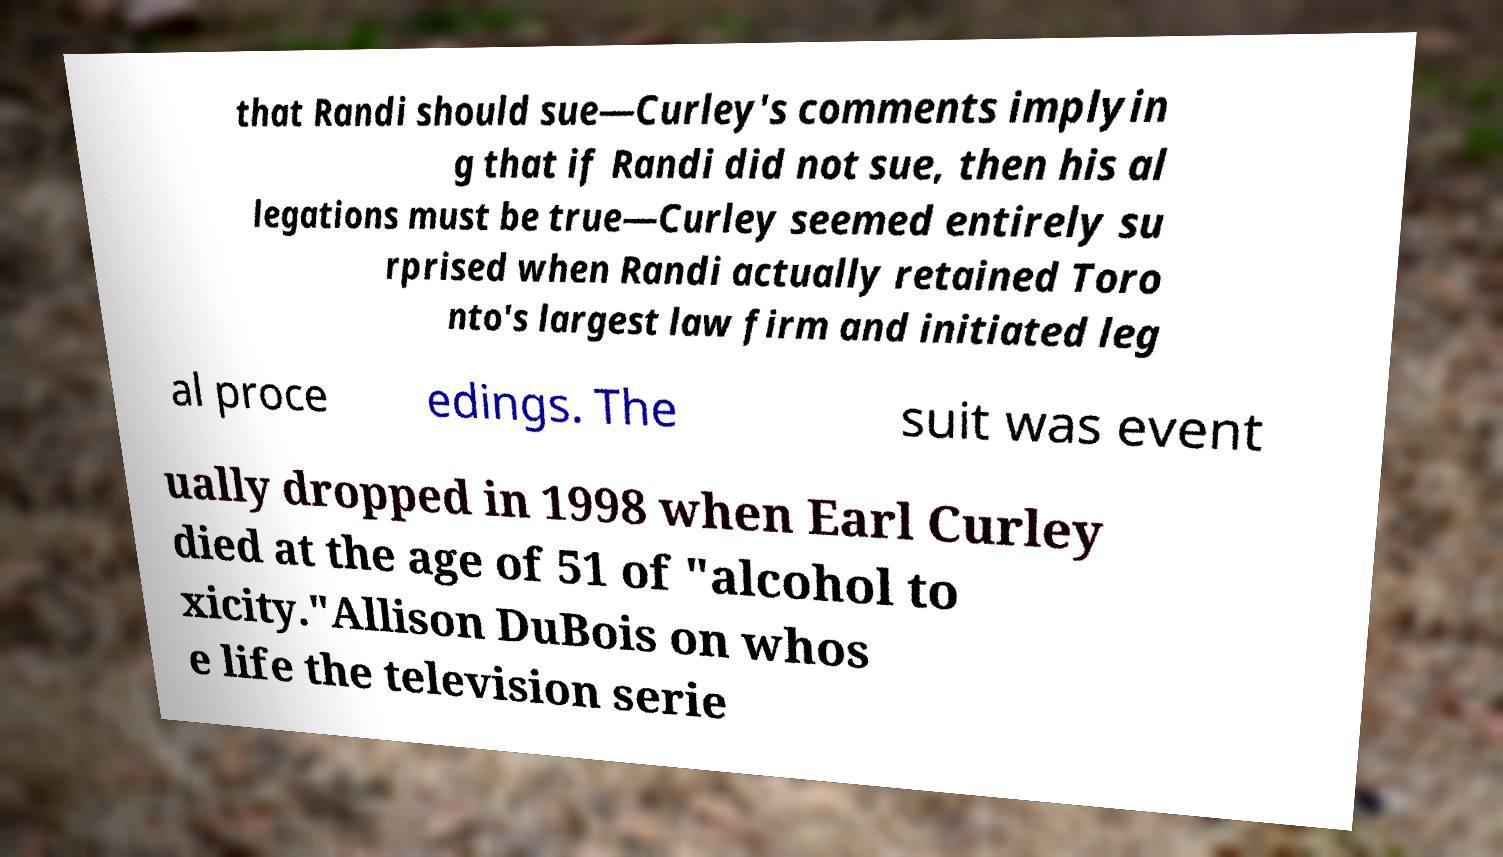What messages or text are displayed in this image? I need them in a readable, typed format. that Randi should sue—Curley's comments implyin g that if Randi did not sue, then his al legations must be true—Curley seemed entirely su rprised when Randi actually retained Toro nto's largest law firm and initiated leg al proce edings. The suit was event ually dropped in 1998 when Earl Curley died at the age of 51 of "alcohol to xicity."Allison DuBois on whos e life the television serie 